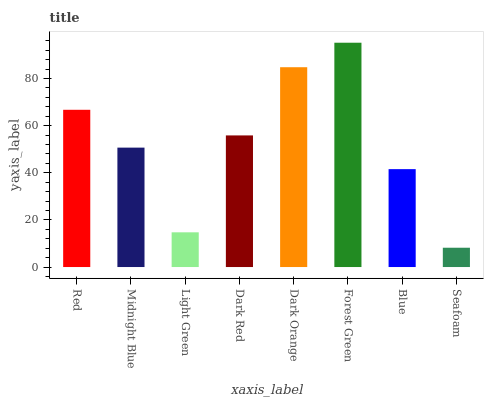Is Seafoam the minimum?
Answer yes or no. Yes. Is Forest Green the maximum?
Answer yes or no. Yes. Is Midnight Blue the minimum?
Answer yes or no. No. Is Midnight Blue the maximum?
Answer yes or no. No. Is Red greater than Midnight Blue?
Answer yes or no. Yes. Is Midnight Blue less than Red?
Answer yes or no. Yes. Is Midnight Blue greater than Red?
Answer yes or no. No. Is Red less than Midnight Blue?
Answer yes or no. No. Is Dark Red the high median?
Answer yes or no. Yes. Is Midnight Blue the low median?
Answer yes or no. Yes. Is Seafoam the high median?
Answer yes or no. No. Is Forest Green the low median?
Answer yes or no. No. 